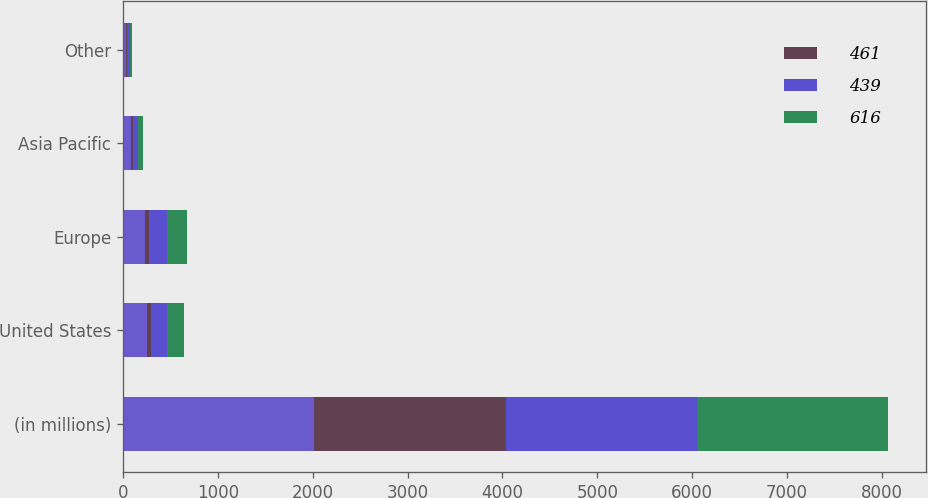Convert chart to OTSL. <chart><loc_0><loc_0><loc_500><loc_500><stacked_bar_chart><ecel><fcel>(in millions)<fcel>United States<fcel>Europe<fcel>Asia Pacific<fcel>Other<nl><fcel>nan<fcel>2016<fcel>255<fcel>237<fcel>87<fcel>37<nl><fcel>461<fcel>2016<fcel>41<fcel>39<fcel>14<fcel>6<nl><fcel>439<fcel>2015<fcel>168<fcel>189<fcel>56<fcel>26<nl><fcel>616<fcel>2014<fcel>180<fcel>206<fcel>53<fcel>22<nl></chart> 